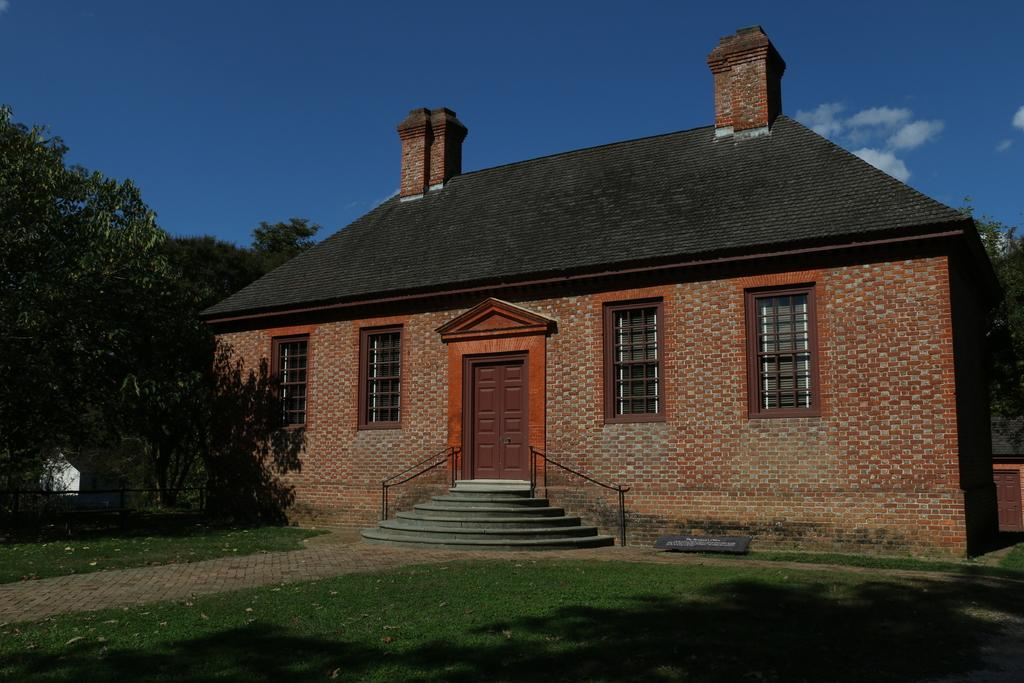What type of vegetation is present on the ground in the front of the image? There is grass on the ground in the front of the image. What can be seen in the background of the image? There are trees and a house in the background of the image. What is the condition of the sky in the image? The sky is cloudy in the image. Where is the ornament located in the image? There is no ornament present in the image. Who is sitting on the throne in the image? There is no throne present in the image. What type of drug can be seen in the image? There is no drug present in the image. 